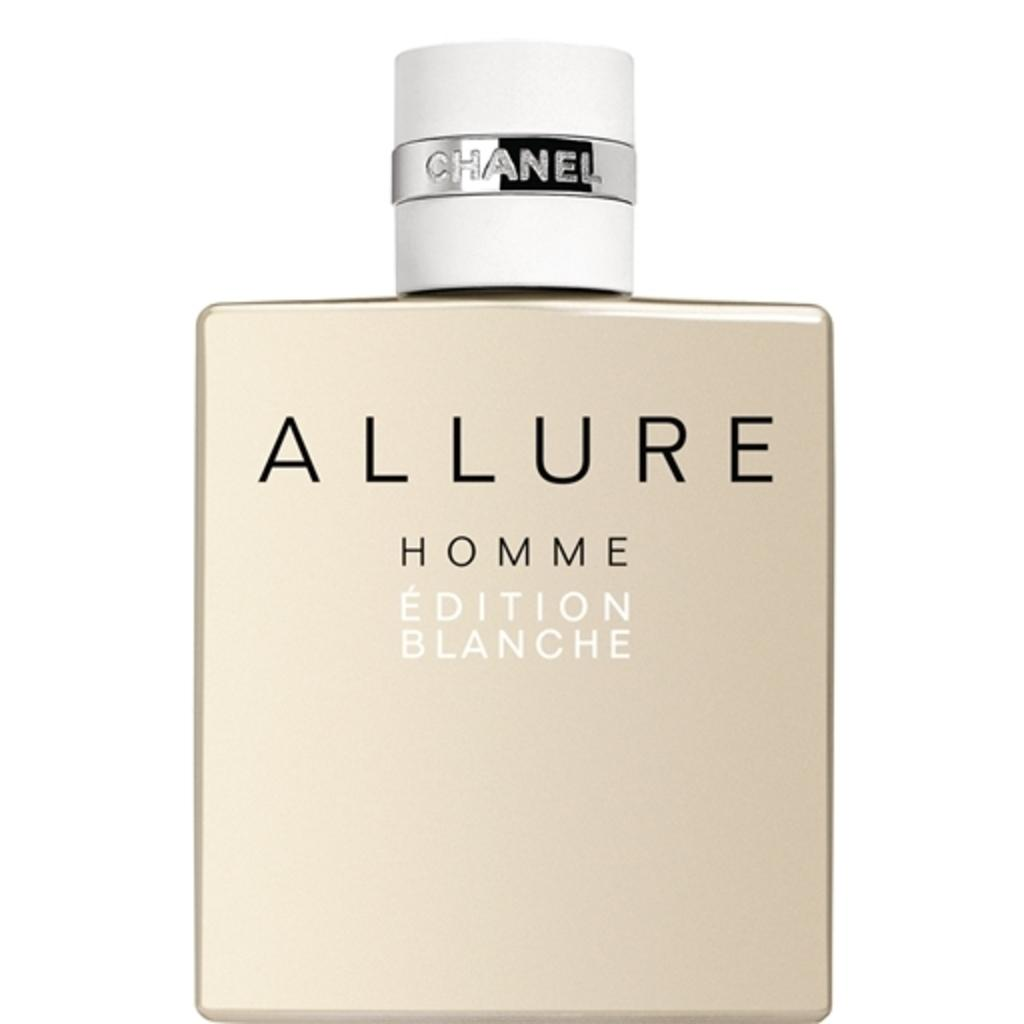<image>
Provide a brief description of the given image. a cologne with the name allure on it 